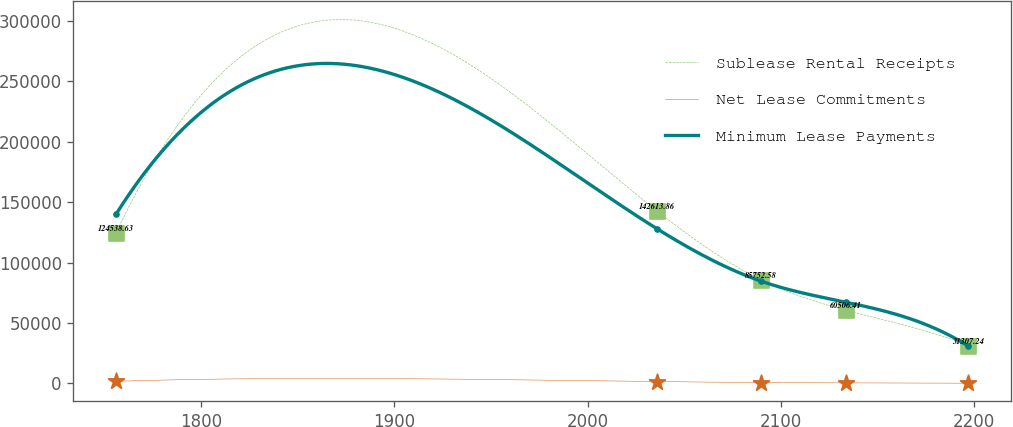Convert chart. <chart><loc_0><loc_0><loc_500><loc_500><line_chart><ecel><fcel>Sublease Rental Receipts<fcel>Net Lease Commitments<fcel>Minimum Lease Payments<nl><fcel>1756.09<fcel>124539<fcel>1701.73<fcel>140074<nl><fcel>2035.99<fcel>142614<fcel>1453.4<fcel>127895<nl><fcel>2089.58<fcel>85752.6<fcel>653.85<fcel>84676.7<nl><fcel>2133.65<fcel>60506.4<fcel>378.27<fcel>67124.2<nl><fcel>2196.83<fcel>31307.2<fcel>109.4<fcel>30870.5<nl></chart> 